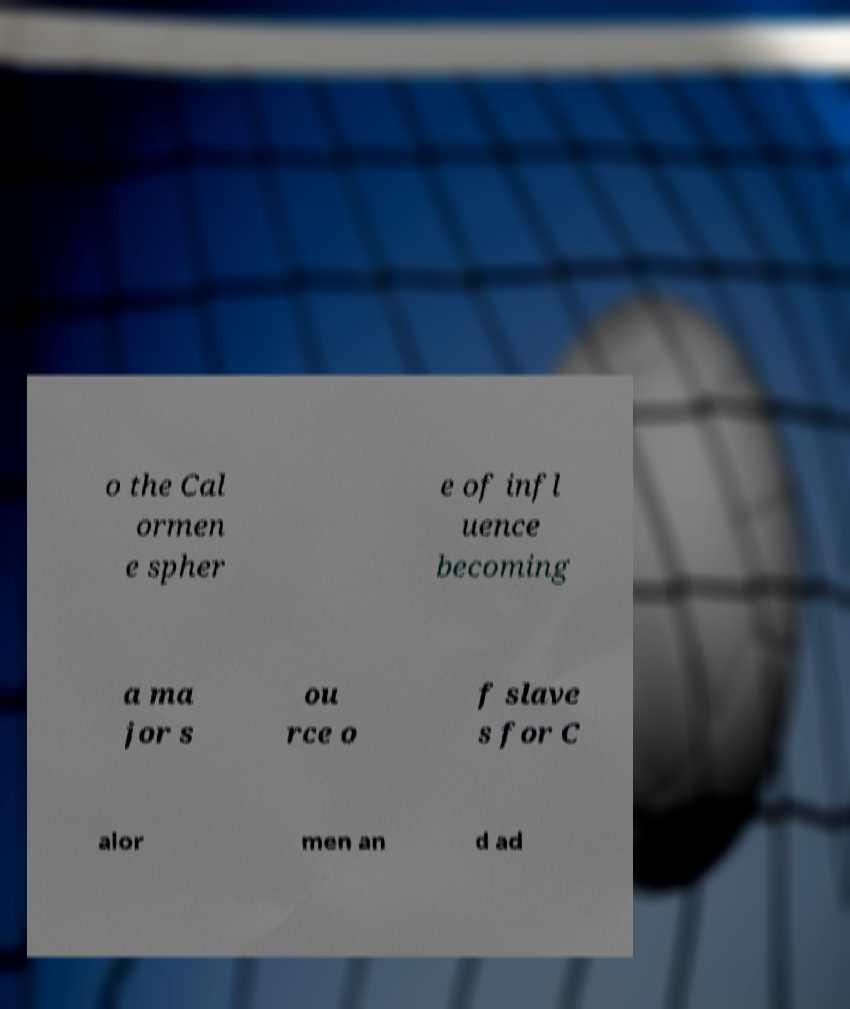Please read and relay the text visible in this image. What does it say? o the Cal ormen e spher e of infl uence becoming a ma jor s ou rce o f slave s for C alor men an d ad 